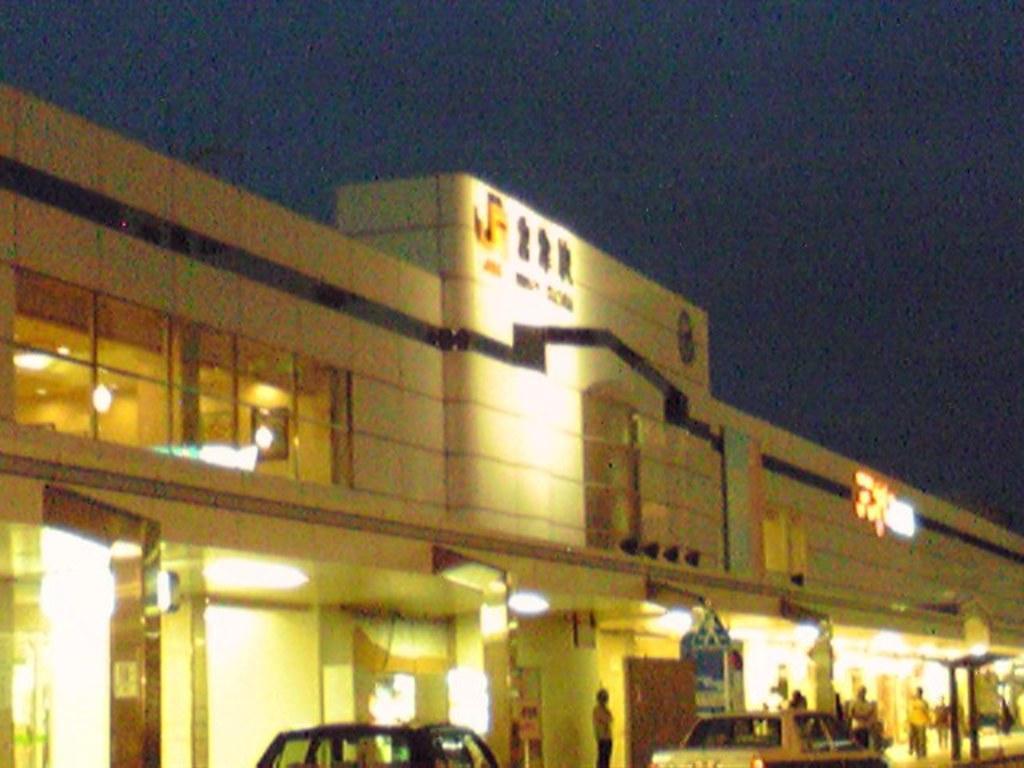Can you describe this image briefly? In this image in the center is a building, and there are some people, vehicles, lights, pillar and there is a text and some other objects. At the top of the image there is sky. 